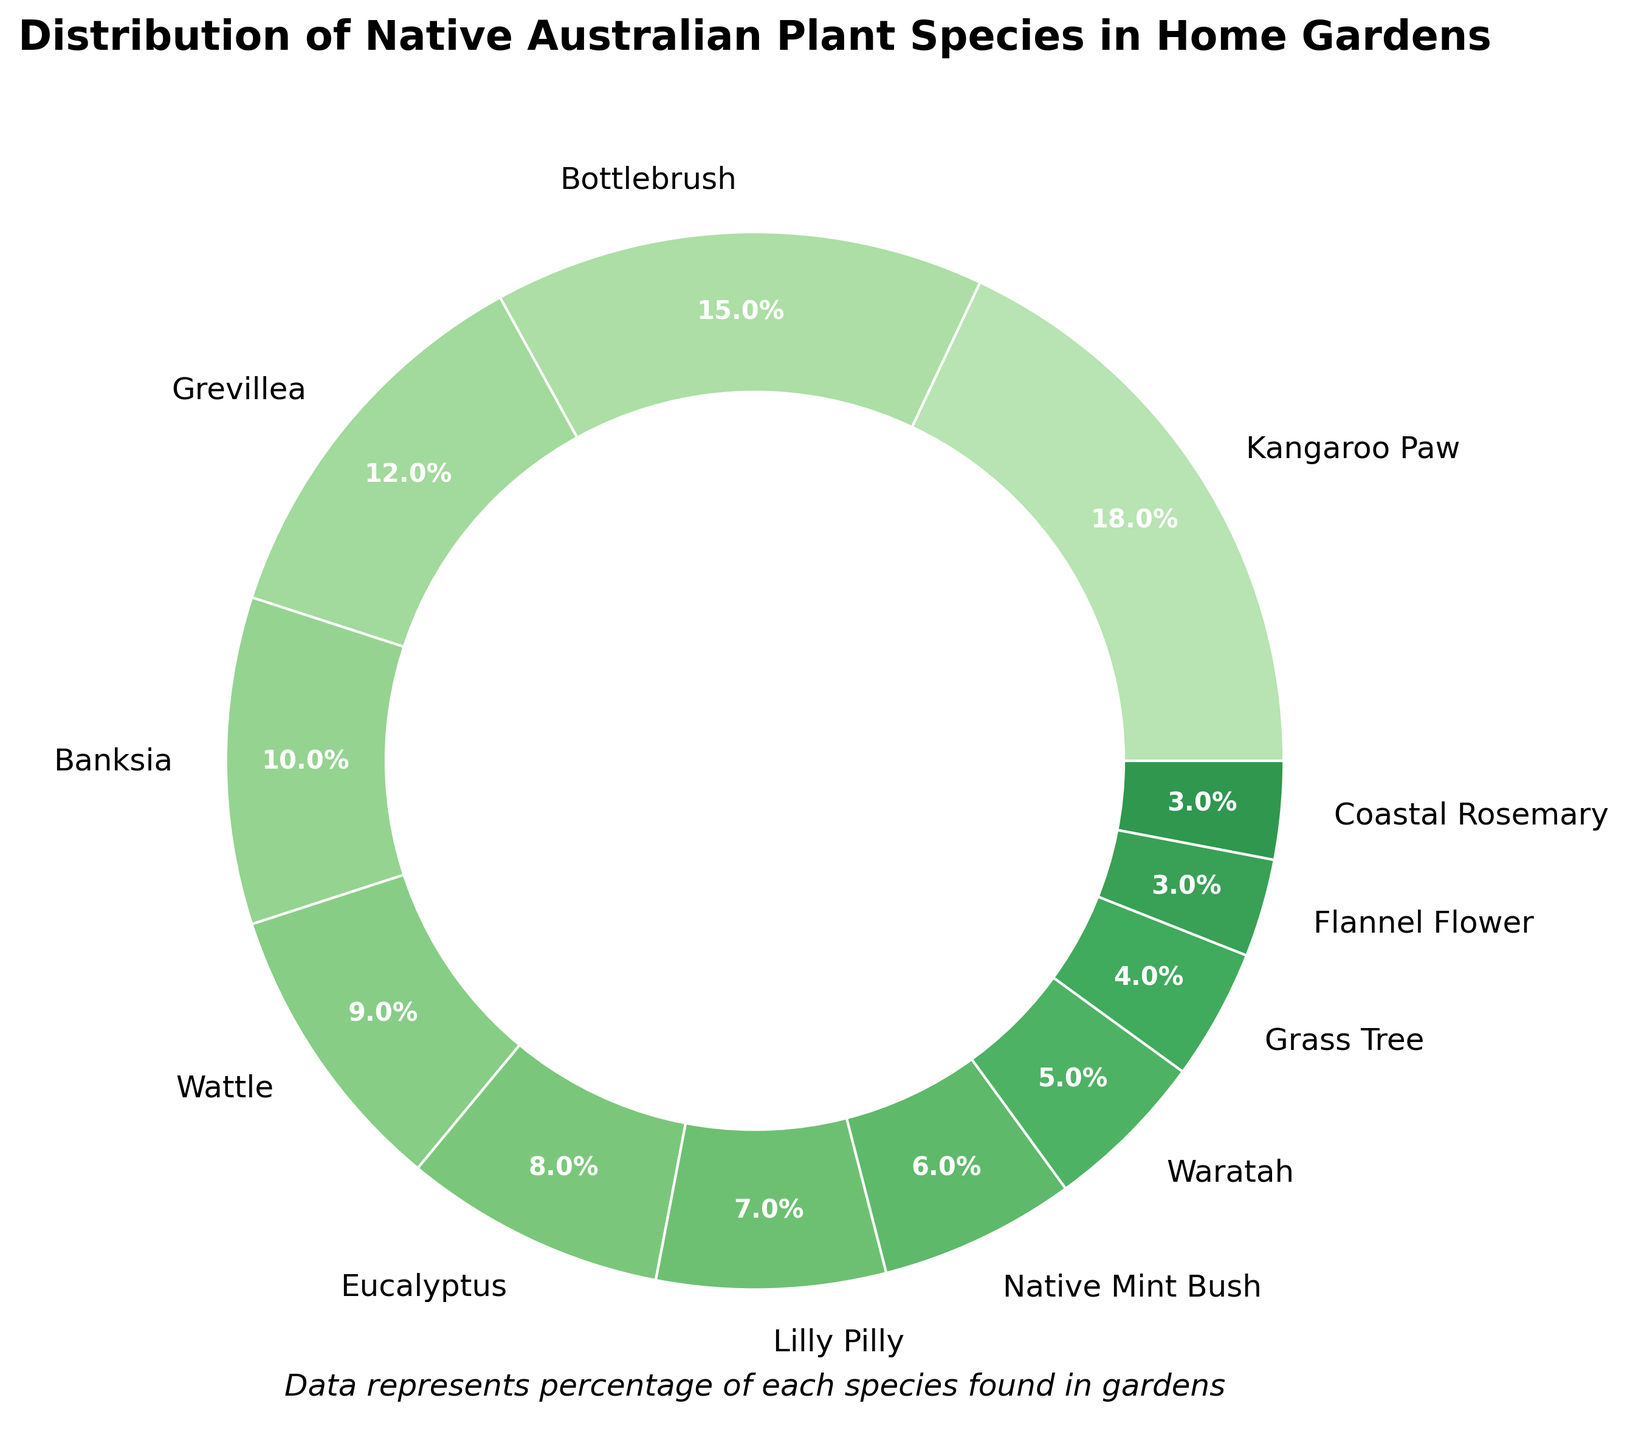What's the most common plant species in home gardens? The chart shows that Kangaroo Paw has the highest percentage at 18%, making it the most common plant species in home gardens.
Answer: Kangaroo Paw Which species has a higher percentage: Grevillea or Bottlebrush? The chart shows Bottlebrush has a percentage of 15%, while Grevillea has a percentage of 12%. Bottlebrush's percentage is higher.
Answer: Bottlebrush What is the combined percentage of Eucalyptus and Wattle? The chart shows Eucalyptus at 8% and Wattle at 9%. Adding these together, 8% + 9% = 17%.
Answer: 17% How much more common is Banksia than Grass Tree in home gardens? The chart shows Banksia at 10% and Grass Tree at 4%. Subtracting Grass Tree's percentage from Banksia's, 10% - 4% = 6%.
Answer: 6% Are there more gardens with Waratah or Coastal Rosemary? The chart shows Waratah at 5% and Coastal Rosemary at 3%. Waratah has a higher percentage.
Answer: Waratah What is the average percentage of the top three most common species? The top three species are Kangaroo Paw (18%), Bottlebrush (15%), and Grevillea (12%). Adding these together, 18% + 15% + 12% = 45%. Dividing by 3, 45/3 = 15%.
Answer: 15% Which species has the least representation in home gardens? The chart shows Coastal Rosemary and Flannel Flower as having the lowest percentages at 3%. Both are equally represented as the least.
Answer: Coastal Rosemary, Flannel Flower What percentage of gardens have either Lilly Pilly or Native Mint Bush? Lilly Pilly is at 7% and Native Mint Bush is at 6%. Adding these together, 7% + 6% = 13%.
Answer: 13% What's the difference in percentage between Bottlebrush and Waratah? Bottlebrush is at 15% while Waratah is at 5%. Subtracting Waratah's percentage from Bottlebrush's, 15% - 5% = 10%.
Answer: 10% 